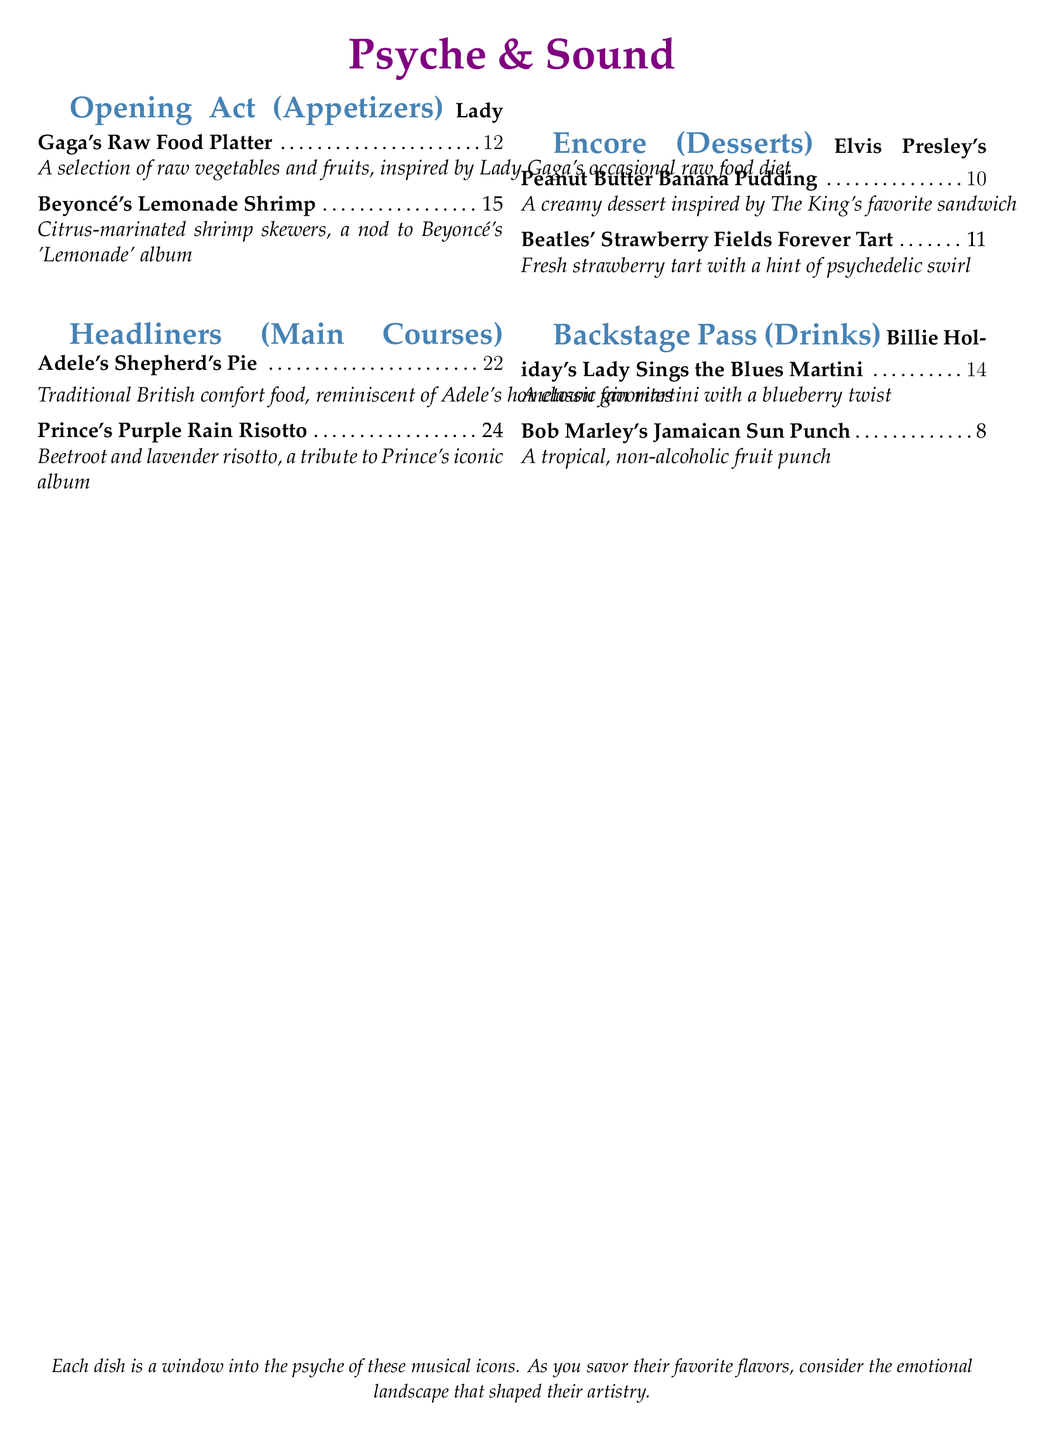what is the name of the restaurant? The name of the restaurant is prominently displayed at the top of the document as "Psyche & Sound."
Answer: Psyche & Sound how much does Beyoncé's Lemonade Shrimp cost? The cost of this dish is listed next to its description, which is $15.
Answer: $15 which musician's dish features beetroot and lavender? The dish that features beetroot and lavender is named "Prince's Purple Rain Risotto."
Answer: Prince what type of dessert is inspired by Elvis Presley? The dessert inspired by Elvis Presley is "Peanut Butter Banana Pudding."
Answer: Peanut Butter Banana Pudding what is the main ingredient in Lady Gaga's Raw Food Platter? The dish's description mentions raw vegetables and fruits as the main components.
Answer: Raw vegetables and fruits name a non-alcoholic drink on the menu. The menu includes "Bob Marley's Jamaican Sun Punch" as a non-alcoholic option.
Answer: Bob Marley's Jamaican Sun Punch how many sections are in the menu? The menu contains a total of four sections including appetizers, main courses, desserts, and drinks.
Answer: Four which dish corresponds with the album 'Strawberry Fields Forever'? The dish that corresponds with this album is "Beatles' Strawberry Fields Forever Tart."
Answer: Beatles' Strawberry Fields Forever Tart what is the price of the dessert item featuring strawberries? The price of the dessert "Beatles' Strawberry Fields Forever Tart" is indicated as $11.
Answer: $11 